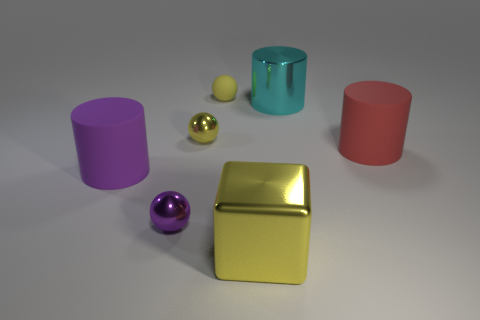How big is the cyan thing?
Offer a terse response. Large. How big is the yellow ball that is behind the yellow ball that is on the left side of the rubber thing that is behind the big shiny cylinder?
Your response must be concise. Small. Are there any other large cylinders made of the same material as the cyan cylinder?
Offer a terse response. No. What shape is the red rubber thing?
Offer a very short reply. Cylinder. The small sphere that is the same material as the red object is what color?
Offer a very short reply. Yellow. How many yellow things are either cubes or balls?
Give a very brief answer. 3. Is the number of large brown things greater than the number of small matte things?
Your answer should be compact. No. What number of things are either things that are to the right of the cyan metallic cylinder or large red rubber things that are in front of the big cyan shiny cylinder?
Give a very brief answer. 1. What color is the shiny cube that is the same size as the purple cylinder?
Make the answer very short. Yellow. Does the large cyan cylinder have the same material as the cube?
Make the answer very short. Yes. 